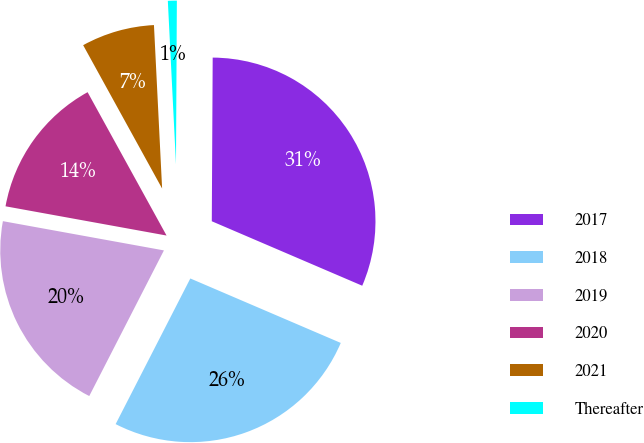Convert chart. <chart><loc_0><loc_0><loc_500><loc_500><pie_chart><fcel>2017<fcel>2018<fcel>2019<fcel>2020<fcel>2021<fcel>Thereafter<nl><fcel>31.36%<fcel>26.1%<fcel>20.32%<fcel>14.13%<fcel>7.22%<fcel>0.88%<nl></chart> 